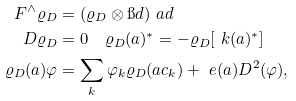<formula> <loc_0><loc_0><loc_500><loc_500>F ^ { \wedge } \varrho _ { D } & = ( \varrho _ { D } \otimes \i d ) \ a d \\ D \varrho _ { D } & = 0 \quad \varrho _ { D } ( a ) ^ { * } = - \varrho _ { D } [ \ k ( a ) ^ { * } ] \\ \varrho _ { D } ( a ) \varphi & = \sum _ { k } \varphi _ { k } \varrho _ { D } ( a c _ { k } ) + \ e ( a ) D ^ { 2 } ( \varphi ) ,</formula> 